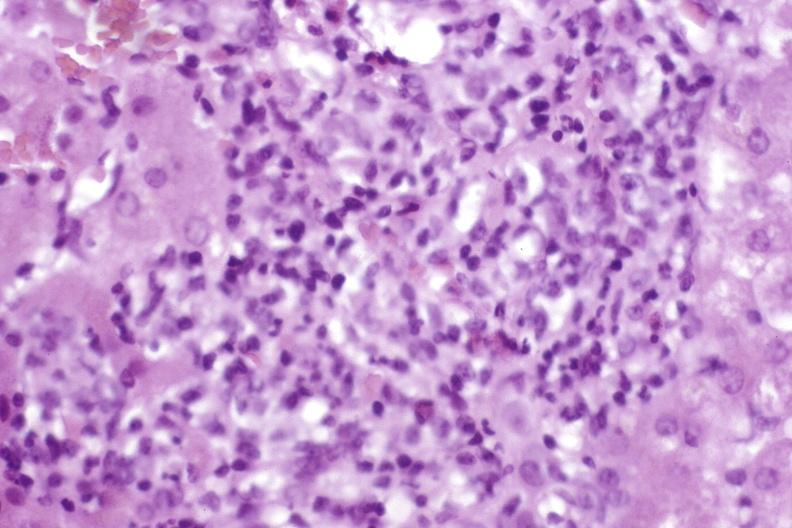s hepatobiliary present?
Answer the question using a single word or phrase. Yes 